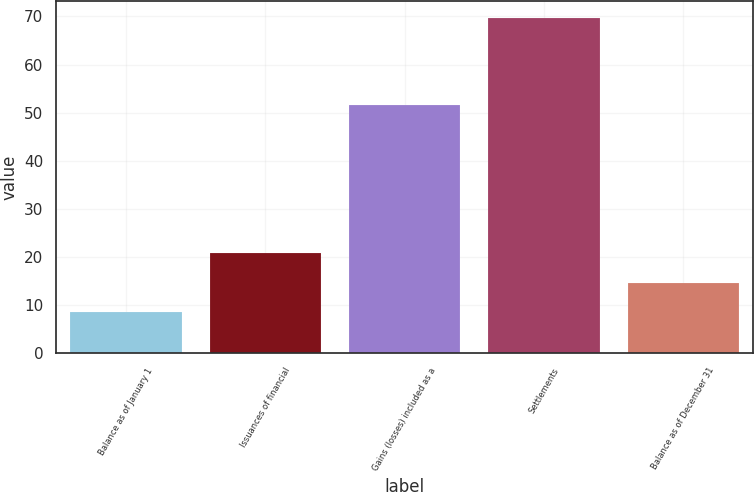Convert chart to OTSL. <chart><loc_0><loc_0><loc_500><loc_500><bar_chart><fcel>Balance as of January 1<fcel>Issuances of financial<fcel>Gains (losses) included as a<fcel>Settlements<fcel>Balance as of December 31<nl><fcel>8.5<fcel>20.74<fcel>51.6<fcel>69.7<fcel>14.62<nl></chart> 